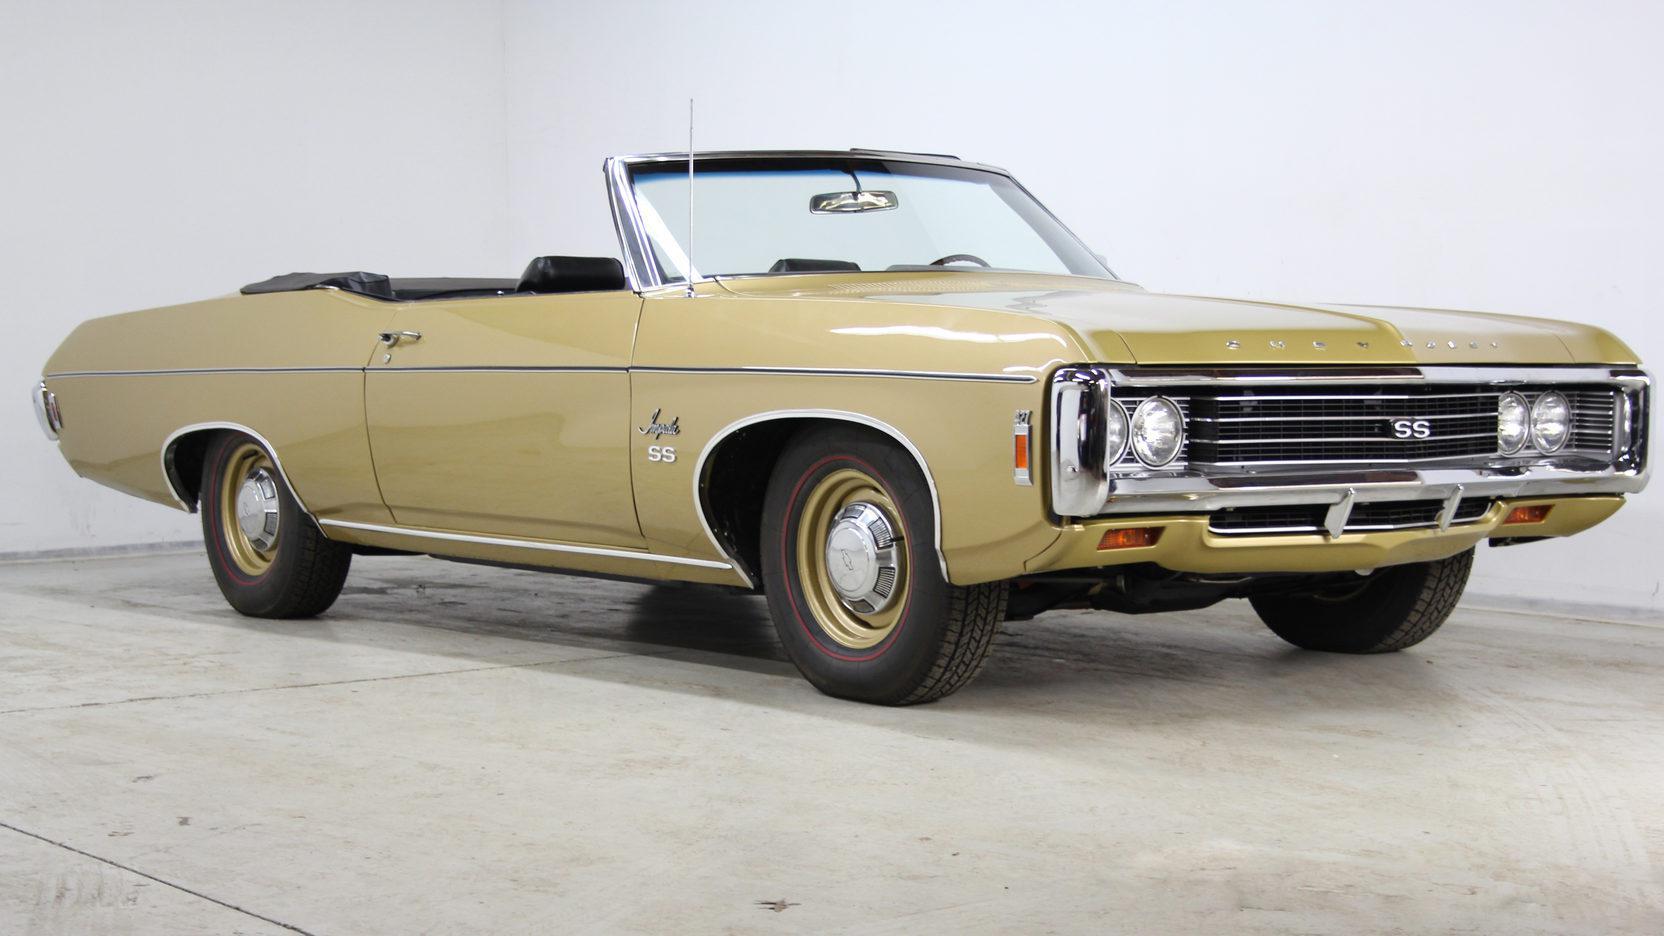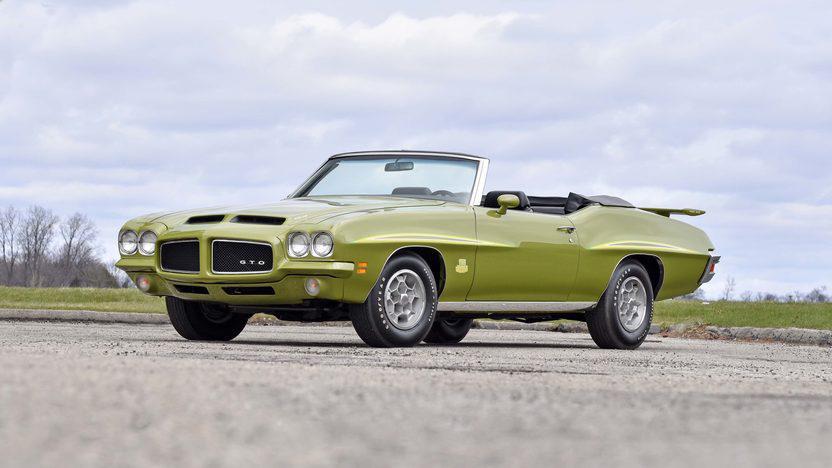The first image is the image on the left, the second image is the image on the right. For the images displayed, is the sentence "Both vehicles are convertibles." factually correct? Answer yes or no. Yes. 